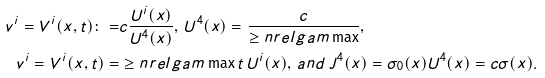<formula> <loc_0><loc_0><loc_500><loc_500>v ^ { i } = V ^ { i } ( x , t ) \colon = & c \frac { U ^ { i } ( x ) } { U ^ { 4 } ( x ) } , \, U ^ { 4 } ( x ) = \frac { c } { \geq n r e l g a m \max } , \\ v ^ { i } = V ^ { i } ( x , t ) = & \geq n r e l g a m \max t \, U ^ { i } ( x ) , \, a n d \, J ^ { 4 } ( x ) = \sigma _ { 0 } ( x ) U ^ { 4 } ( x ) = c \sigma ( x ) .</formula> 